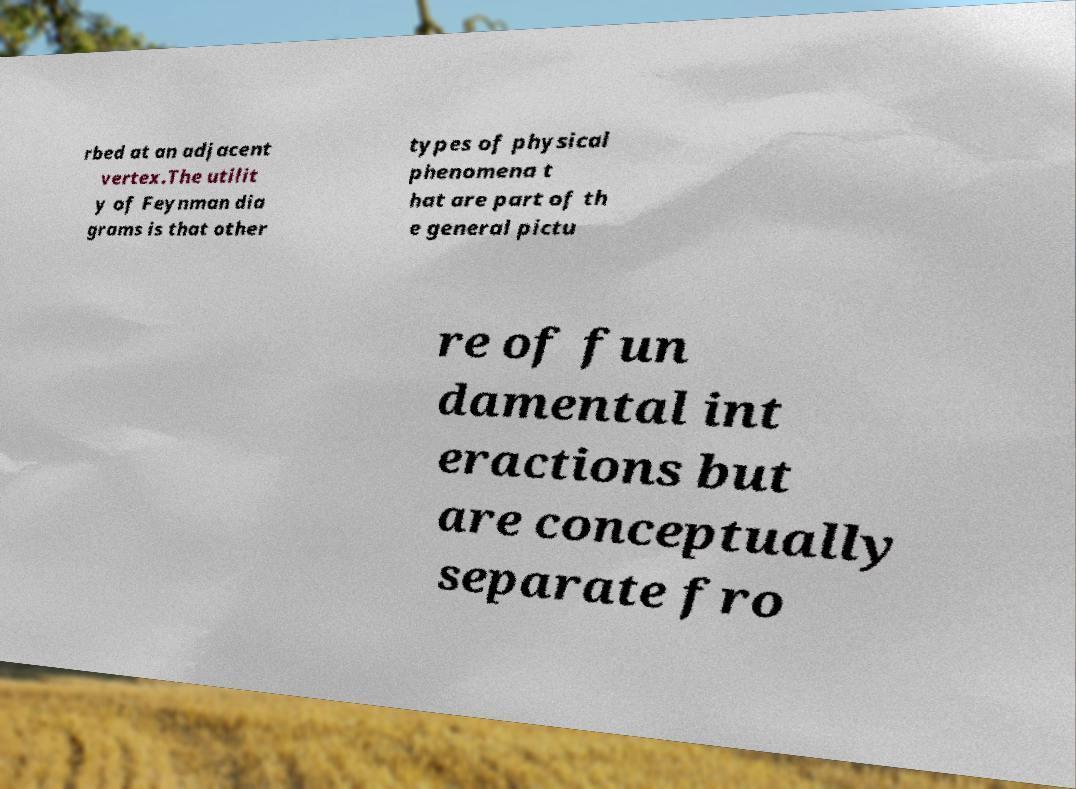Please read and relay the text visible in this image. What does it say? rbed at an adjacent vertex.The utilit y of Feynman dia grams is that other types of physical phenomena t hat are part of th e general pictu re of fun damental int eractions but are conceptually separate fro 